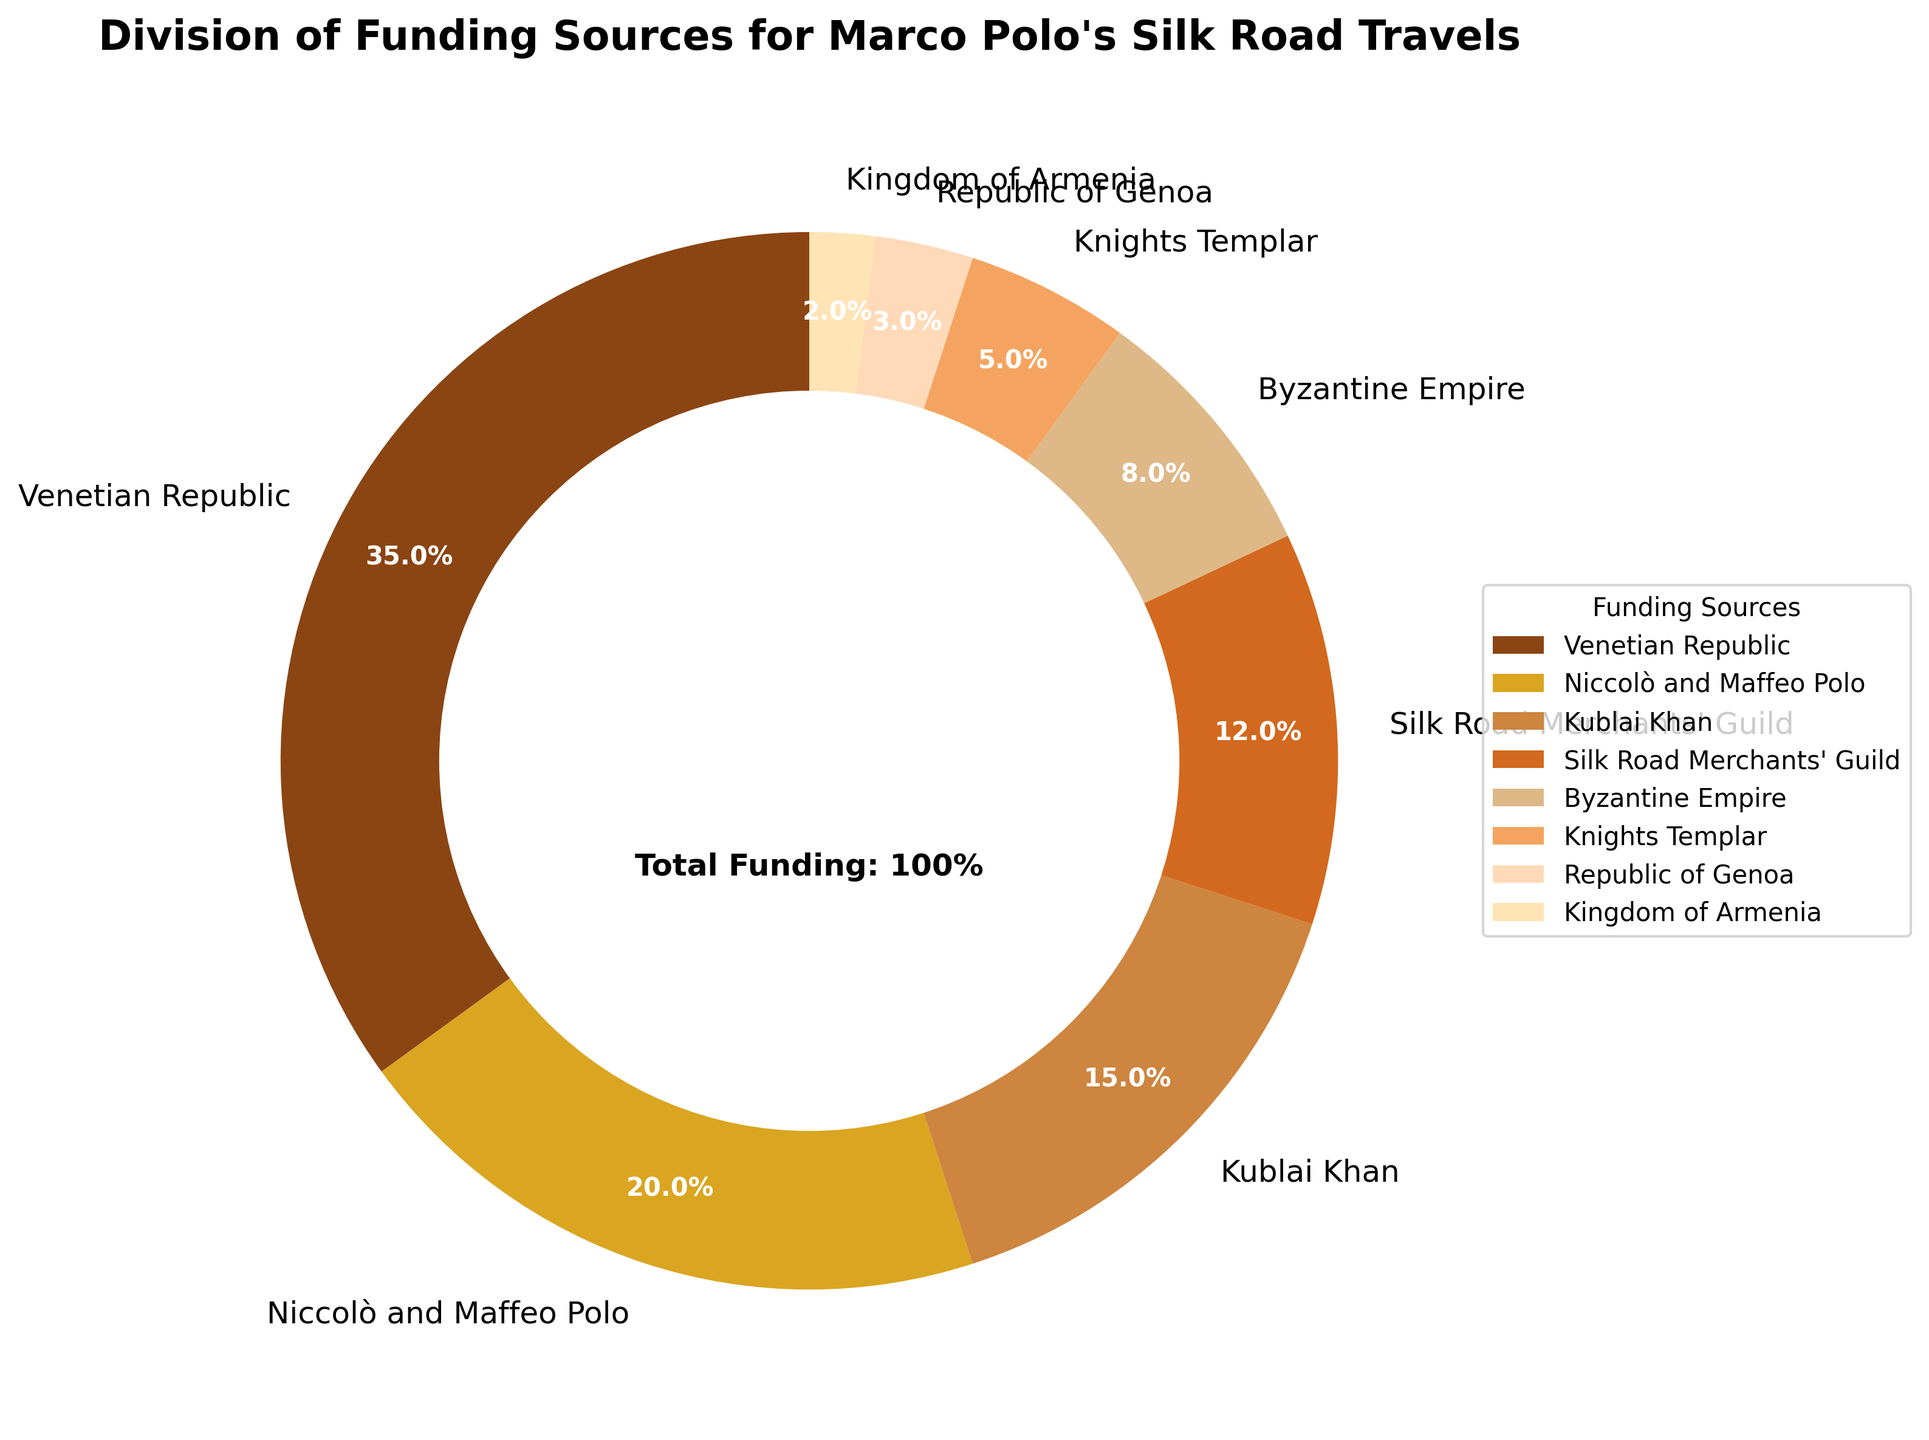What is the largest funding source for Marco Polo's travels? The largest segment in the pie chart is labeled "Venetian Republic," which accounts for 35%. Therefore, the Venetian Republic is the largest funding source.
Answer: Venetian Republic Which funding sources collectively contribute more than 50% of the total funding? Adding the percentages of the funding sources: Venetian Republic (35%), Niccolò and Maffeo Polo (20%), Kublai Khan (15%). 35% + 20% + 15% = 70%, which is more than 50%.
Answer: Venetian Republic, Niccolò and Maffeo Polo, Kublai Khan How much more funding did the Venetian Republic provide compared to the Byzantine Empire? The pie chart shows the Venetian Republic provided 35% and the Byzantine Empire provided 8%. The difference is 35% - 8% = 27%.
Answer: 27% Which funding source contributed the least? The smallest segment in the pie chart is labeled "Kingdom of Armenia," which accounts for 2%.
Answer: Kingdom of Armenia What proportion of the funding is provided by the Knights Templar and the Silk Road Merchants' Guild combined? Adding the percentages of Knights Templar (5%) and Silk Road Merchants' Guild (12%): 5% + 12% = 17%.
Answer: 17% Which two funding sources together equal the largest single funding source? The largest funding source is the Venetian Republic at 35%. Adding any combination of percentages must sum to 35%: Niccolò and Maffeo Polo (20%) + Silk Road Merchants' Guild (12%) = 32%, which is not enough. Adding Niccolò and Maffeo Polo (20%) + Kublai Khan (15%) = 35%, which is equal to the largest funding source.
Answer: Niccolò and Maffeo Polo and Kublai Khan Compared to the Republic of Genoa, how many times more funding did the Venetian Republic provide? The Venetian Republic provided 35% and the Republic of Genoa provided 3%. To find how many times more: 35% / 3% = 35/3 ≈ 11.67.
Answer: 11.67 times What is the sum of the contributions from the Byzantine Empire and the Kingdom of Armenia? The pie chart shows that the Byzantine Empire provided 8% and the Kingdom of Armenia provided 2%. Sum is 8% + 2% = 10%.
Answer: 10% Among the listed funding sources, which one had a contribution greater than the sum of the Republic of Genoa and Kingdom of Armenia? The sum of the Republic of Genoa (3%) and Kingdom of Armenia (2%) is 5%. Any funding source with a percentage greater than 5% is eligible. Byzantine Empire (8%), Silk Road Merchants' Guild (12%), Kublai Khan (15%), Niccolò and Maffeo Polo (20%), Venetian Republic (35%). Therefore, five sources qualify.
Answer: Venetian Republic, Niccolò and Maffeo Polo, Kublai Khan, Silk Road Merchants' Guild, Byzantine Empire How much funding did all non-Venetian sources provide in total? Subtract the percentage of the Venetian Republic (35%) from the total (100%): 100% - 35% = 65%.
Answer: 65% 